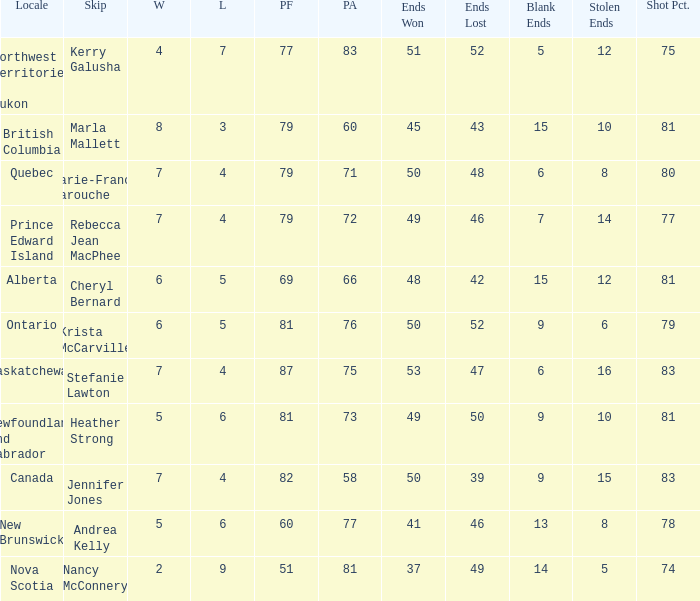Where was the shot pct 78? New Brunswick. 